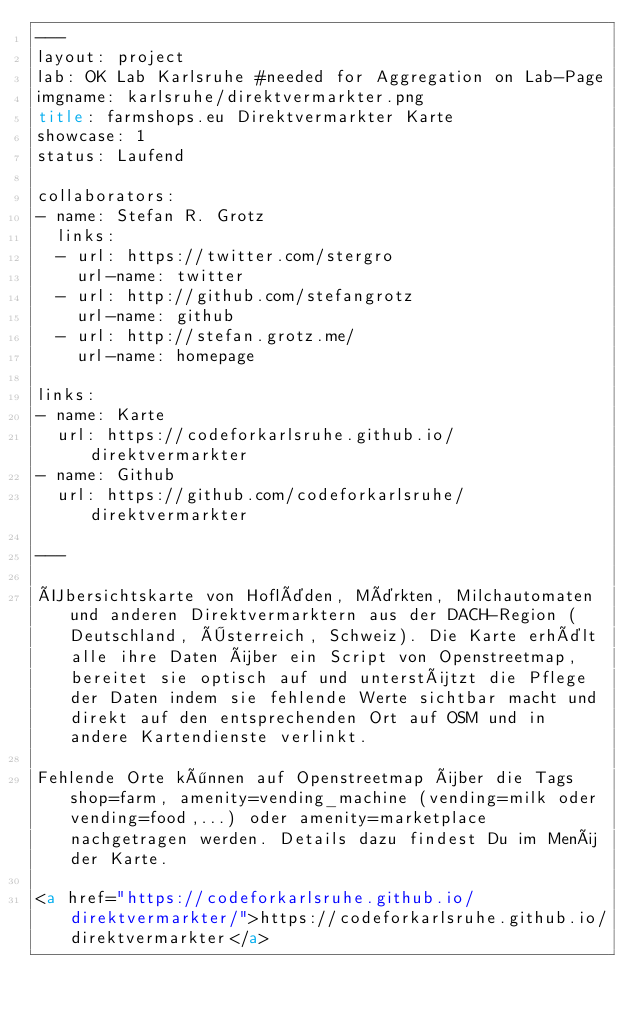Convert code to text. <code><loc_0><loc_0><loc_500><loc_500><_HTML_>---
layout: project
lab: OK Lab Karlsruhe #needed for Aggregation on Lab-Page
imgname: karlsruhe/direktvermarkter.png
title: farmshops.eu Direktvermarkter Karte
showcase: 1
status: Laufend

collaborators:
- name: Stefan R. Grotz
  links:
  - url: https://twitter.com/stergro
    url-name: twitter
  - url: http://github.com/stefangrotz
    url-name: github
  - url: http://stefan.grotz.me/
    url-name: homepage

links:
- name: Karte
  url: https://codeforkarlsruhe.github.io/direktvermarkter
- name: Github
  url: https://github.com/codeforkarlsruhe/direktvermarkter

---

Übersichtskarte von Hofläden, Märkten, Milchautomaten und anderen Direktvermarktern aus der DACH-Region (Deutschland, Österreich, Schweiz). Die Karte erhält alle ihre Daten über ein Script von Openstreetmap, bereitet sie optisch auf und unterstützt die Pflege der Daten indem sie fehlende Werte sichtbar macht und direkt auf den entsprechenden Ort auf OSM und in andere Kartendienste verlinkt. 

Fehlende Orte können auf Openstreetmap über die Tags shop=farm, amenity=vending_machine (vending=milk oder vending=food,...) oder amenity=marketplace nachgetragen werden. Details dazu findest Du im Menü der Karte.

<a href="https://codeforkarlsruhe.github.io/direktvermarkter/">https://codeforkarlsruhe.github.io/direktvermarkter</a>
</code> 